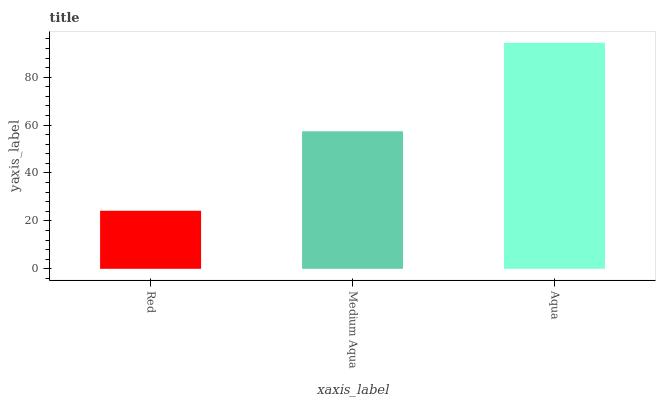Is Red the minimum?
Answer yes or no. Yes. Is Aqua the maximum?
Answer yes or no. Yes. Is Medium Aqua the minimum?
Answer yes or no. No. Is Medium Aqua the maximum?
Answer yes or no. No. Is Medium Aqua greater than Red?
Answer yes or no. Yes. Is Red less than Medium Aqua?
Answer yes or no. Yes. Is Red greater than Medium Aqua?
Answer yes or no. No. Is Medium Aqua less than Red?
Answer yes or no. No. Is Medium Aqua the high median?
Answer yes or no. Yes. Is Medium Aqua the low median?
Answer yes or no. Yes. Is Aqua the high median?
Answer yes or no. No. Is Red the low median?
Answer yes or no. No. 